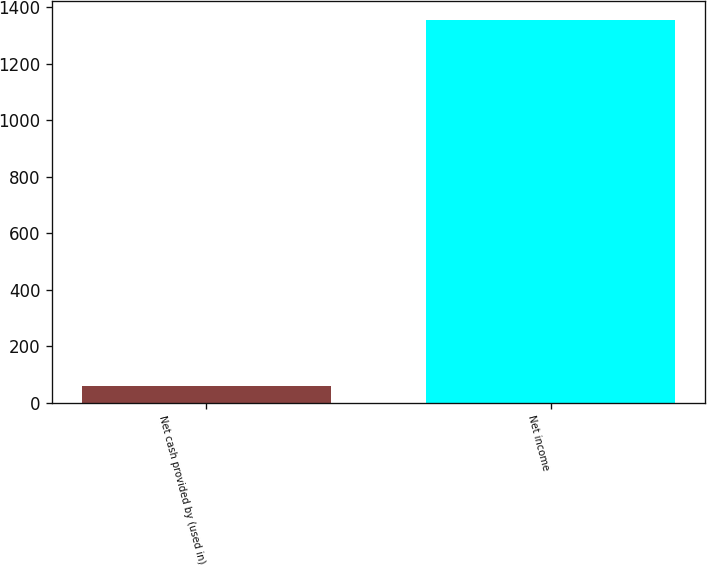<chart> <loc_0><loc_0><loc_500><loc_500><bar_chart><fcel>Net cash provided by (used in)<fcel>Net income<nl><fcel>59<fcel>1355<nl></chart> 